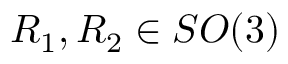Convert formula to latex. <formula><loc_0><loc_0><loc_500><loc_500>R _ { 1 } , R _ { 2 } \in S O ( 3 )</formula> 